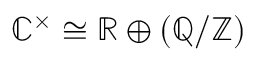<formula> <loc_0><loc_0><loc_500><loc_500>\mathbb { C } ^ { \times } \cong \mathbb { R } \oplus ( \mathbb { Q } / \mathbb { Z } )</formula> 